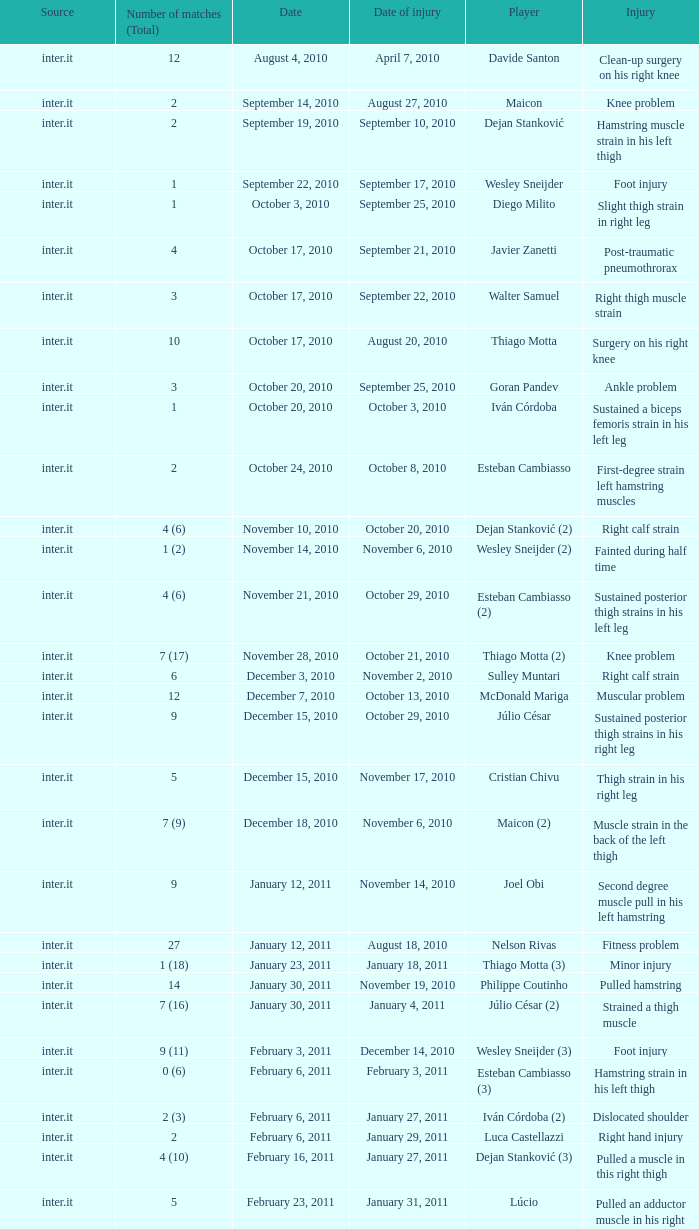Can you give me this table as a dict? {'header': ['Source', 'Number of matches (Total)', 'Date', 'Date of injury', 'Player', 'Injury'], 'rows': [['inter.it', '12', 'August 4, 2010', 'April 7, 2010', 'Davide Santon', 'Clean-up surgery on his right knee'], ['inter.it', '2', 'September 14, 2010', 'August 27, 2010', 'Maicon', 'Knee problem'], ['inter.it', '2', 'September 19, 2010', 'September 10, 2010', 'Dejan Stanković', 'Hamstring muscle strain in his left thigh'], ['inter.it', '1', 'September 22, 2010', 'September 17, 2010', 'Wesley Sneijder', 'Foot injury'], ['inter.it', '1', 'October 3, 2010', 'September 25, 2010', 'Diego Milito', 'Slight thigh strain in right leg'], ['inter.it', '4', 'October 17, 2010', 'September 21, 2010', 'Javier Zanetti', 'Post-traumatic pneumothrorax'], ['inter.it', '3', 'October 17, 2010', 'September 22, 2010', 'Walter Samuel', 'Right thigh muscle strain'], ['inter.it', '10', 'October 17, 2010', 'August 20, 2010', 'Thiago Motta', 'Surgery on his right knee'], ['inter.it', '3', 'October 20, 2010', 'September 25, 2010', 'Goran Pandev', 'Ankle problem'], ['inter.it', '1', 'October 20, 2010', 'October 3, 2010', 'Iván Córdoba', 'Sustained a biceps femoris strain in his left leg'], ['inter.it', '2', 'October 24, 2010', 'October 8, 2010', 'Esteban Cambiasso', 'First-degree strain left hamstring muscles'], ['inter.it', '4 (6)', 'November 10, 2010', 'October 20, 2010', 'Dejan Stanković (2)', 'Right calf strain'], ['inter.it', '1 (2)', 'November 14, 2010', 'November 6, 2010', 'Wesley Sneijder (2)', 'Fainted during half time'], ['inter.it', '4 (6)', 'November 21, 2010', 'October 29, 2010', 'Esteban Cambiasso (2)', 'Sustained posterior thigh strains in his left leg'], ['inter.it', '7 (17)', 'November 28, 2010', 'October 21, 2010', 'Thiago Motta (2)', 'Knee problem'], ['inter.it', '6', 'December 3, 2010', 'November 2, 2010', 'Sulley Muntari', 'Right calf strain'], ['inter.it', '12', 'December 7, 2010', 'October 13, 2010', 'McDonald Mariga', 'Muscular problem'], ['inter.it', '9', 'December 15, 2010', 'October 29, 2010', 'Júlio César', 'Sustained posterior thigh strains in his right leg'], ['inter.it', '5', 'December 15, 2010', 'November 17, 2010', 'Cristian Chivu', 'Thigh strain in his right leg'], ['inter.it', '7 (9)', 'December 18, 2010', 'November 6, 2010', 'Maicon (2)', 'Muscle strain in the back of the left thigh'], ['inter.it', '9', 'January 12, 2011', 'November 14, 2010', 'Joel Obi', 'Second degree muscle pull in his left hamstring'], ['inter.it', '27', 'January 12, 2011', 'August 18, 2010', 'Nelson Rivas', 'Fitness problem'], ['inter.it', '1 (18)', 'January 23, 2011', 'January 18, 2011', 'Thiago Motta (3)', 'Minor injury'], ['inter.it', '14', 'January 30, 2011', 'November 19, 2010', 'Philippe Coutinho', 'Pulled hamstring'], ['inter.it', '7 (16)', 'January 30, 2011', 'January 4, 2011', 'Júlio César (2)', 'Strained a thigh muscle'], ['inter.it', '9 (11)', 'February 3, 2011', 'December 14, 2010', 'Wesley Sneijder (3)', 'Foot injury'], ['inter.it', '0 (6)', 'February 6, 2011', 'February 3, 2011', 'Esteban Cambiasso (3)', 'Hamstring strain in his left thigh'], ['inter.it', '2 (3)', 'February 6, 2011', 'January 27, 2011', 'Iván Córdoba (2)', 'Dislocated shoulder'], ['inter.it', '2', 'February 6, 2011', 'January 29, 2011', 'Luca Castellazzi', 'Right hand injury'], ['inter.it', '4 (10)', 'February 16, 2011', 'January 27, 2011', 'Dejan Stanković (3)', 'Pulled a muscle in this right thigh'], ['inter.it', '5', 'February 23, 2011', 'January 31, 2011', 'Lúcio', 'Pulled an adductor muscle in his right thigh']]} What is the date of injury when the injury is sustained posterior thigh strains in his left leg? October 29, 2010. 